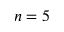Convert formula to latex. <formula><loc_0><loc_0><loc_500><loc_500>n = 5</formula> 